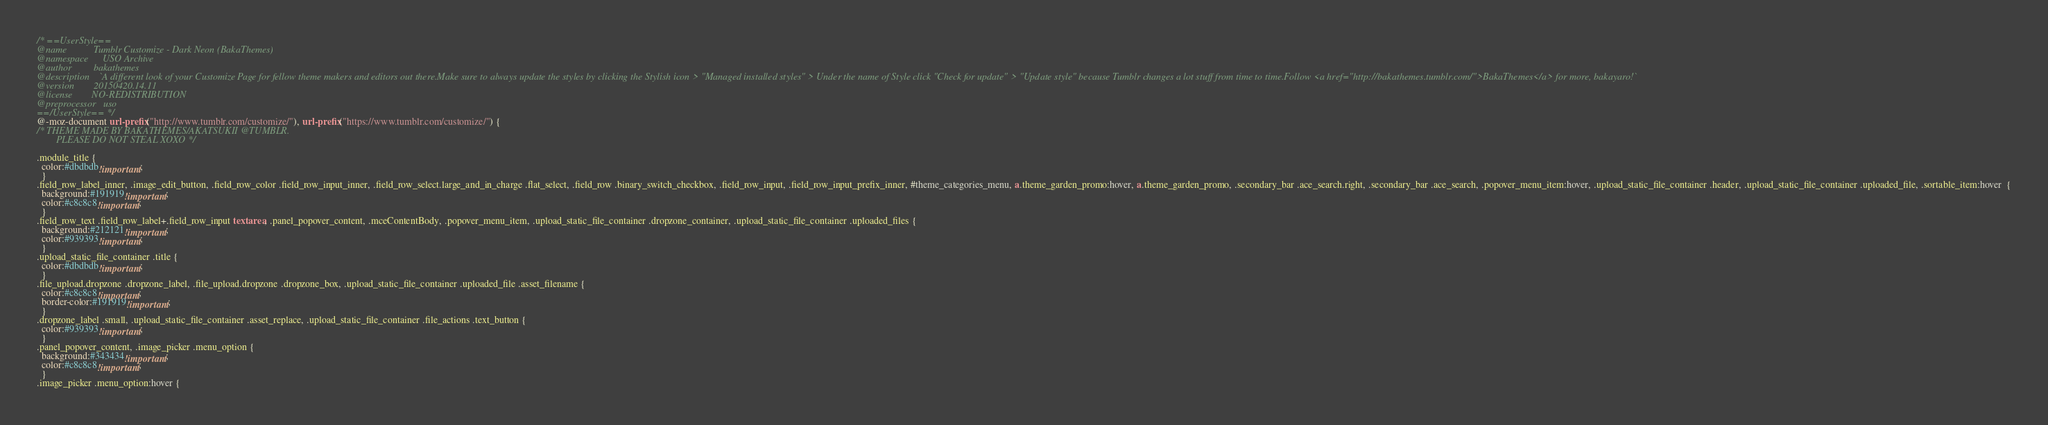Convert code to text. <code><loc_0><loc_0><loc_500><loc_500><_CSS_>/* ==UserStyle==
@name           Tumblr Customize - Dark Neon (BakaThemes)
@namespace      USO Archive
@author         bakathemes
@description    `A different look of your Customize Page for fellow theme makers and editors out there.Make sure to always update the styles by clicking the Stylish icon > "Managed installed styles" > Under the name of Style click "Check for update" > "Update style" because Tumblr changes a lot stuff from time to time.Follow <a href="http://bakathemes.tumblr.com/">BakaThemes</a> for more, bakayaro!`
@version        20150420.14.11
@license        NO-REDISTRIBUTION
@preprocessor   uso
==/UserStyle== */
@-moz-document url-prefix("http://www.tumblr.com/customize/"), url-prefix("https://www.tumblr.com/customize/") {
/* THEME MADE BY BAKATHEMES/AKATSUKII @TUMBLR.
		PLEASE DO NOT STEAL XOXO */

.module_title {
  color:#dbdbdb!important;
  }
.field_row_label_inner, .image_edit_button, .field_row_color .field_row_input_inner, .field_row_select.large_and_in_charge .flat_select, .field_row .binary_switch_checkbox, .field_row_input, .field_row_input_prefix_inner, #theme_categories_menu, a.theme_garden_promo:hover, a.theme_garden_promo, .secondary_bar .ace_search.right, .secondary_bar .ace_search, .popover_menu_item:hover, .upload_static_file_container .header, .upload_static_file_container .uploaded_file, .sortable_item:hover  {
  background:#191919!important;
  color:#c8c8c8!important;
  }
.field_row_text .field_row_label+.field_row_input textarea, .panel_popover_content, .mceContentBody, .popover_menu_item, .upload_static_file_container .dropzone_container, .upload_static_file_container .uploaded_files {
  background:#212121!important;
  color:#939393!important;
  }
.upload_static_file_container .title {
  color:#dbdbdb!important;
  }        
.file_upload.dropzone .dropzone_label, .file_upload.dropzone .dropzone_box, .upload_static_file_container .uploaded_file .asset_filename {
  color:#c8c8c8!important;
  border-color:#191919!important; 
  }
.dropzone_label .small, .upload_static_file_container .asset_replace, .upload_static_file_container .file_actions .text_button {
  color:#939393!important;
  }        
.panel_popover_content, .image_picker .menu_option {
  background:#343434!important;
  color:#c8c8c8!important;
  }
.image_picker .menu_option:hover {</code> 